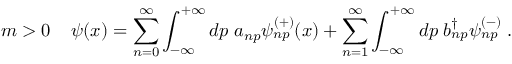<formula> <loc_0><loc_0><loc_500><loc_500>m > 0 \, \psi ( x ) = \sum _ { n = 0 } ^ { \infty } \int _ { - \infty } ^ { + \infty } d p \, a _ { n p } \psi _ { n p } ^ { ( + ) } ( x ) + \sum _ { n = 1 } ^ { \infty } \int _ { - \infty } ^ { + \infty } d p \, b _ { n p } ^ { \dag } \psi _ { n p } ^ { ( - ) } \, .</formula> 